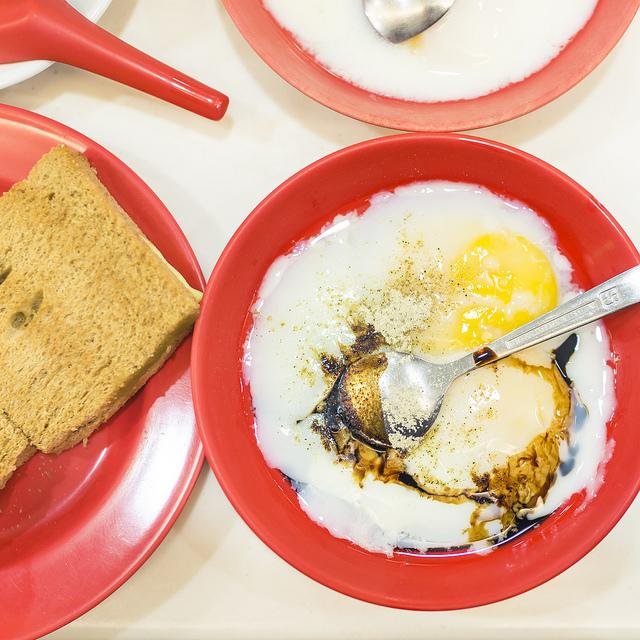Which food offers the most protein? egg 